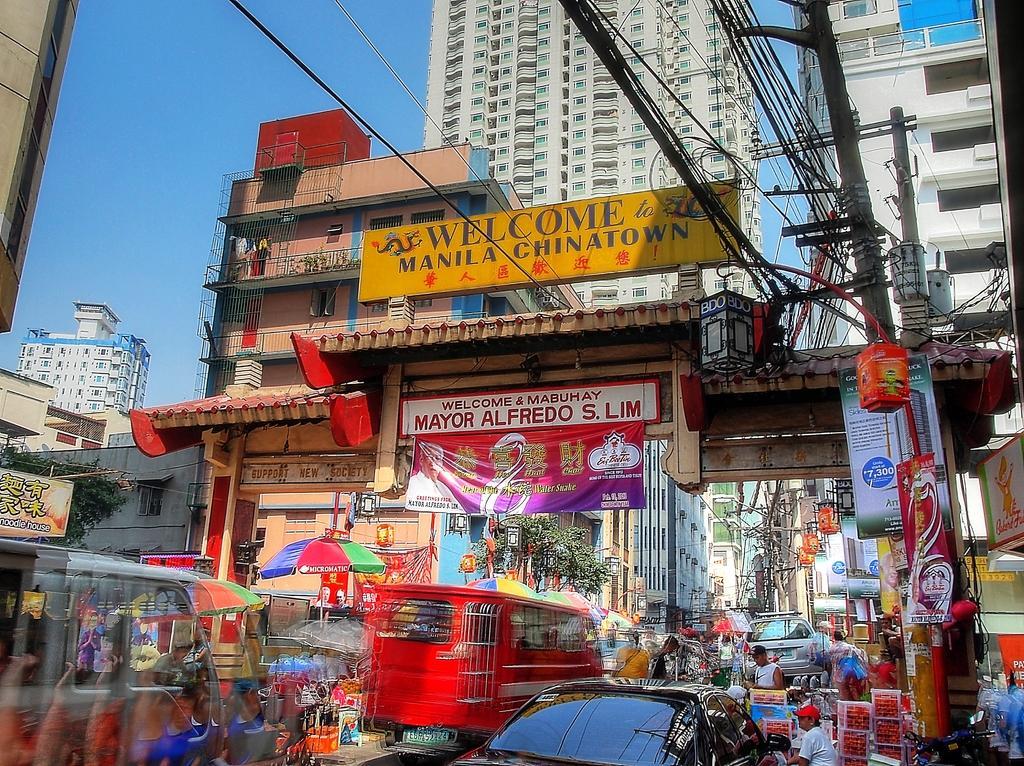In one or two sentences, can you explain what this image depicts? This image is taken outside, where we can see vehicles moving on the road and many objects like boxes, poles, lights, banners, buildings, name board on the top of the building, cables, apartments, and the sky are seen in it. 